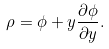<formula> <loc_0><loc_0><loc_500><loc_500>\rho = \phi + y \frac { \partial \phi } { \partial y } .</formula> 